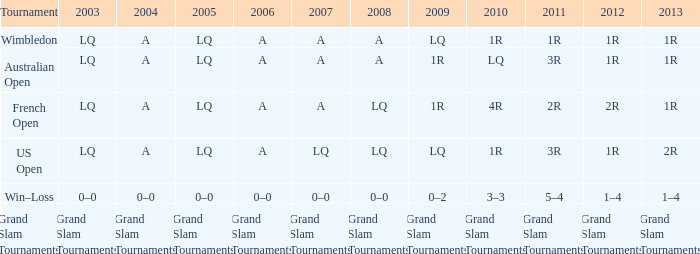Which tournament has a 2013 of 1r, and a 2012 of 1r? Australian Open, Wimbledon. 